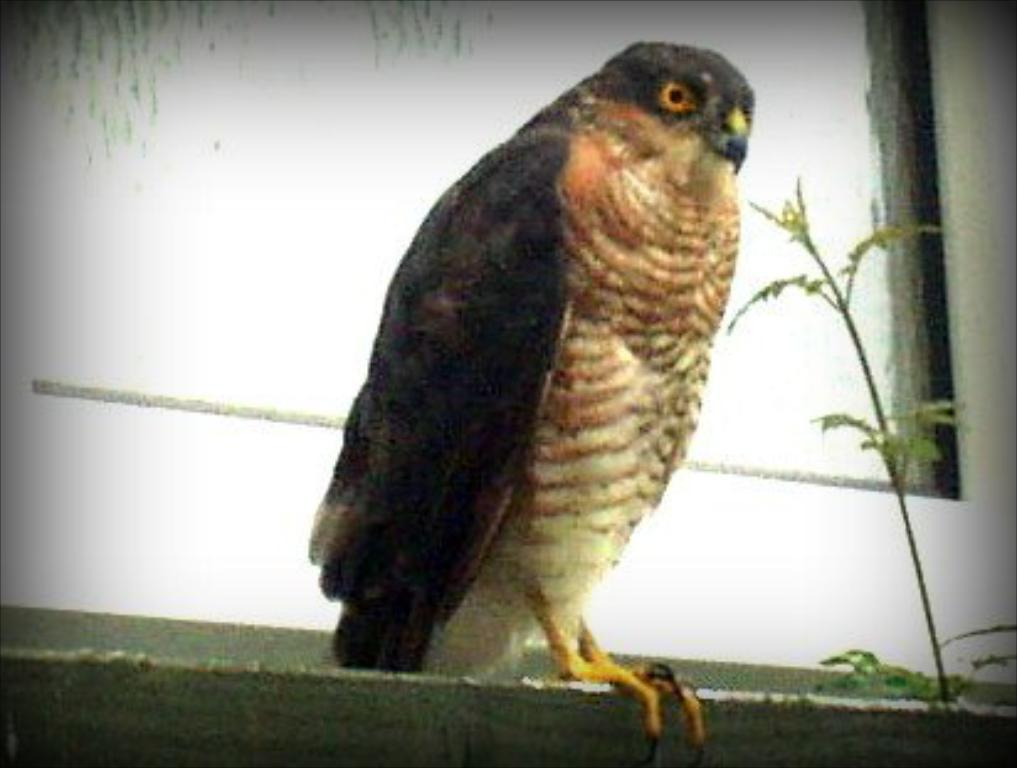What is the main object in the image? There is an aboard in the image. What is located beside the aboard? There is a plant beside the aboard. Can you describe the bird in the image? A bird is visible in front of a window in the image. Where is the girl sitting with her plate of food in the image? There is no girl or plate of food present in the image. 